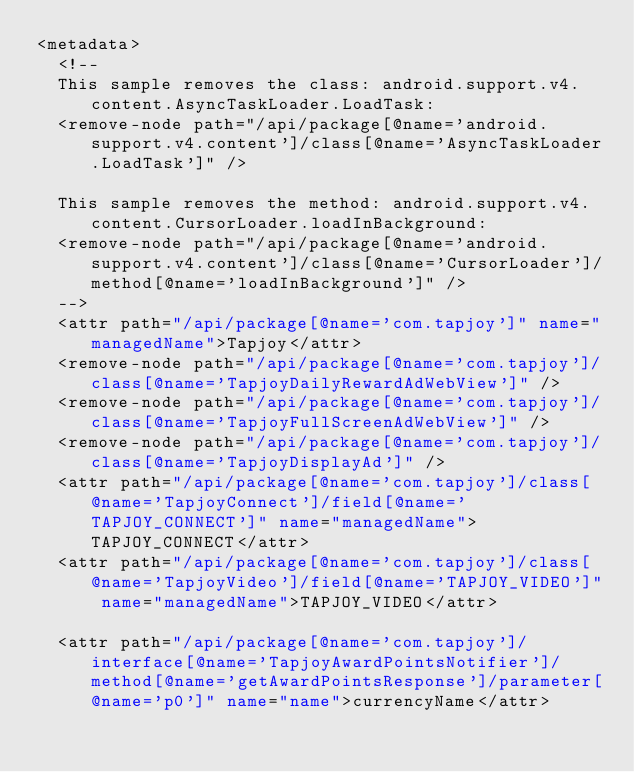Convert code to text. <code><loc_0><loc_0><loc_500><loc_500><_XML_><metadata>
  <!--
  This sample removes the class: android.support.v4.content.AsyncTaskLoader.LoadTask:
  <remove-node path="/api/package[@name='android.support.v4.content']/class[@name='AsyncTaskLoader.LoadTask']" />
  
  This sample removes the method: android.support.v4.content.CursorLoader.loadInBackground:
  <remove-node path="/api/package[@name='android.support.v4.content']/class[@name='CursorLoader']/method[@name='loadInBackground']" />
  -->
  <attr path="/api/package[@name='com.tapjoy']" name="managedName">Tapjoy</attr>
  <remove-node path="/api/package[@name='com.tapjoy']/class[@name='TapjoyDailyRewardAdWebView']" />
  <remove-node path="/api/package[@name='com.tapjoy']/class[@name='TapjoyFullScreenAdWebView']" />
  <remove-node path="/api/package[@name='com.tapjoy']/class[@name='TapjoyDisplayAd']" />
  <attr path="/api/package[@name='com.tapjoy']/class[@name='TapjoyConnect']/field[@name='TAPJOY_CONNECT']" name="managedName">TAPJOY_CONNECT</attr>
  <attr path="/api/package[@name='com.tapjoy']/class[@name='TapjoyVideo']/field[@name='TAPJOY_VIDEO']" name="managedName">TAPJOY_VIDEO</attr>

  <attr path="/api/package[@name='com.tapjoy']/interface[@name='TapjoyAwardPointsNotifier']/method[@name='getAwardPointsResponse']/parameter[@name='p0']" name="name">currencyName</attr></code> 